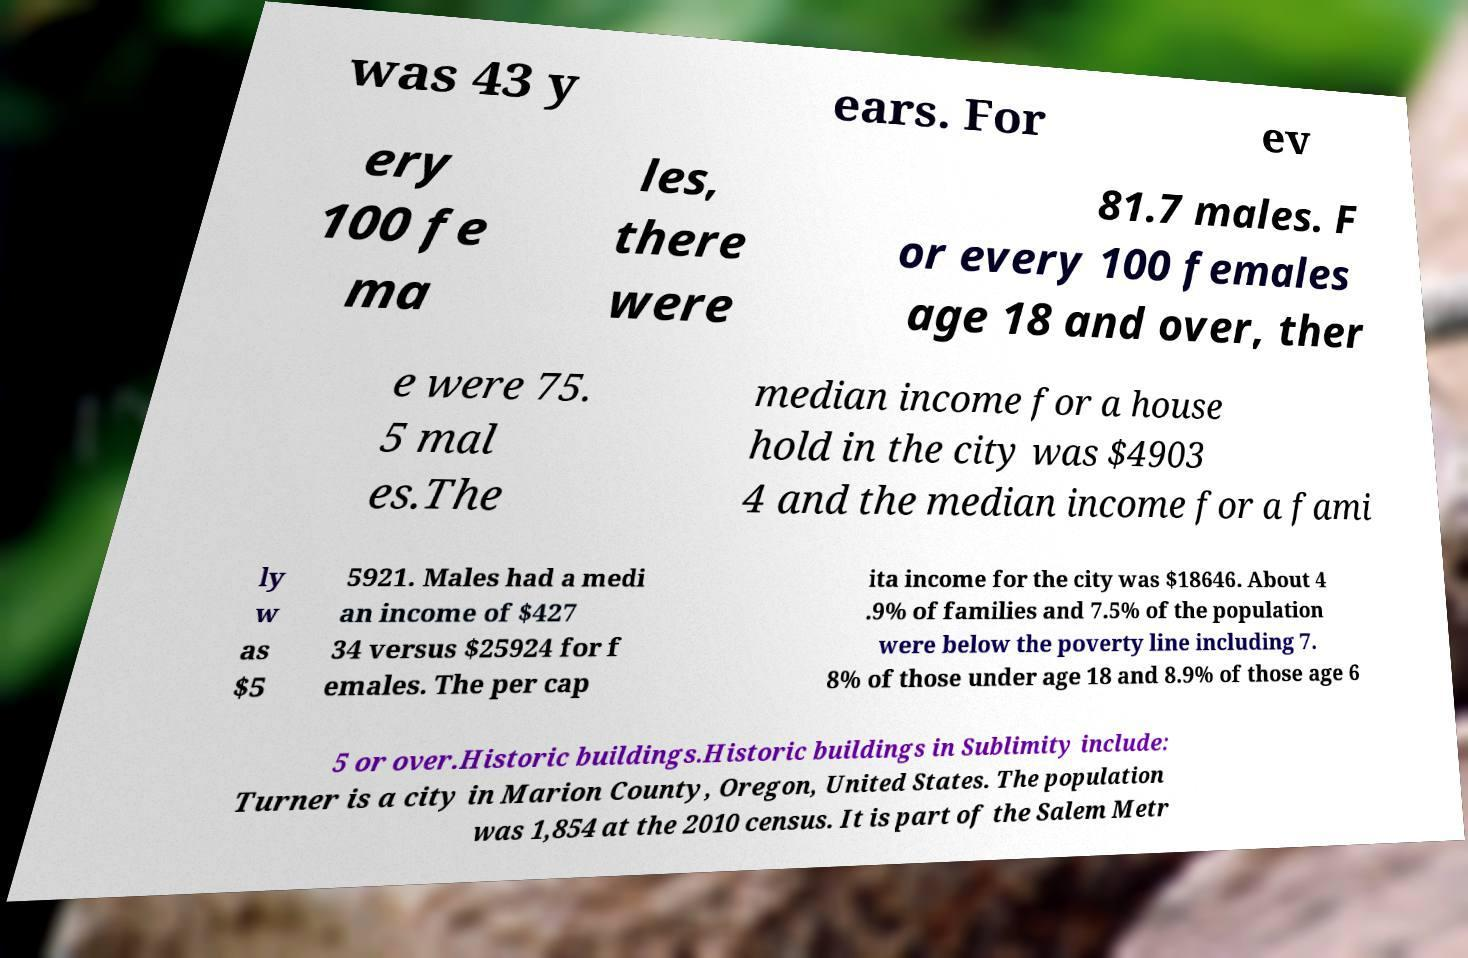For documentation purposes, I need the text within this image transcribed. Could you provide that? was 43 y ears. For ev ery 100 fe ma les, there were 81.7 males. F or every 100 females age 18 and over, ther e were 75. 5 mal es.The median income for a house hold in the city was $4903 4 and the median income for a fami ly w as $5 5921. Males had a medi an income of $427 34 versus $25924 for f emales. The per cap ita income for the city was $18646. About 4 .9% of families and 7.5% of the population were below the poverty line including 7. 8% of those under age 18 and 8.9% of those age 6 5 or over.Historic buildings.Historic buildings in Sublimity include: Turner is a city in Marion County, Oregon, United States. The population was 1,854 at the 2010 census. It is part of the Salem Metr 